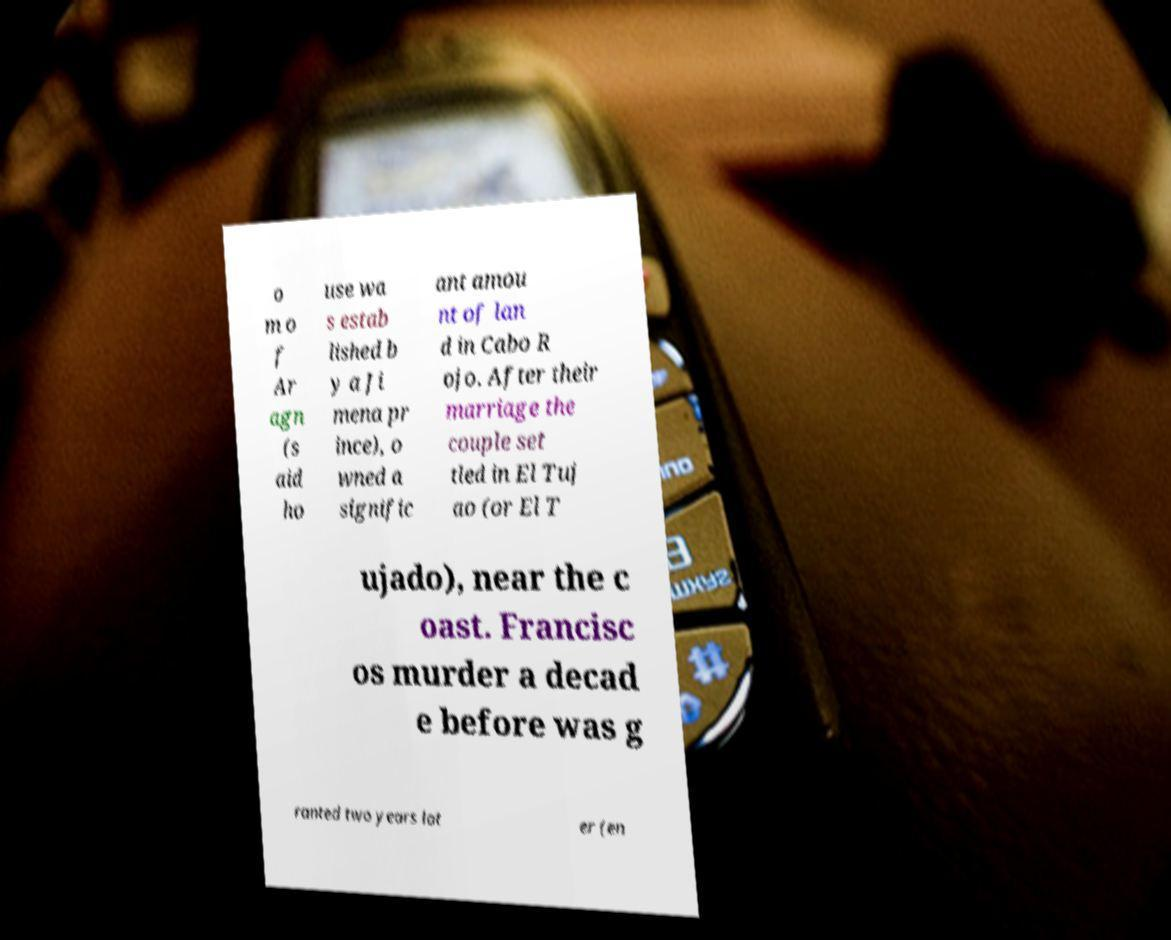Please identify and transcribe the text found in this image. o m o f Ar agn (s aid ho use wa s estab lished b y a Ji mena pr ince), o wned a signific ant amou nt of lan d in Cabo R ojo. After their marriage the couple set tled in El Tuj ao (or El T ujado), near the c oast. Francisc os murder a decad e before was g ranted two years lat er (en 